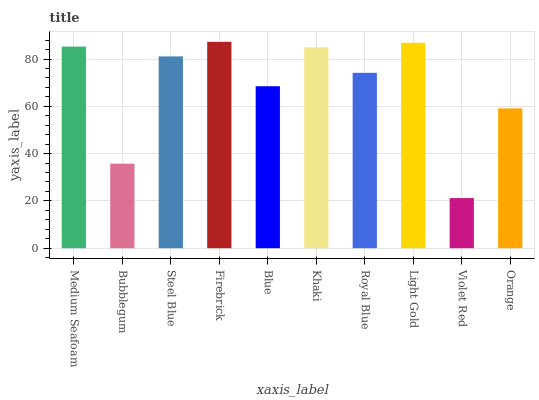Is Violet Red the minimum?
Answer yes or no. Yes. Is Firebrick the maximum?
Answer yes or no. Yes. Is Bubblegum the minimum?
Answer yes or no. No. Is Bubblegum the maximum?
Answer yes or no. No. Is Medium Seafoam greater than Bubblegum?
Answer yes or no. Yes. Is Bubblegum less than Medium Seafoam?
Answer yes or no. Yes. Is Bubblegum greater than Medium Seafoam?
Answer yes or no. No. Is Medium Seafoam less than Bubblegum?
Answer yes or no. No. Is Steel Blue the high median?
Answer yes or no. Yes. Is Royal Blue the low median?
Answer yes or no. Yes. Is Violet Red the high median?
Answer yes or no. No. Is Khaki the low median?
Answer yes or no. No. 